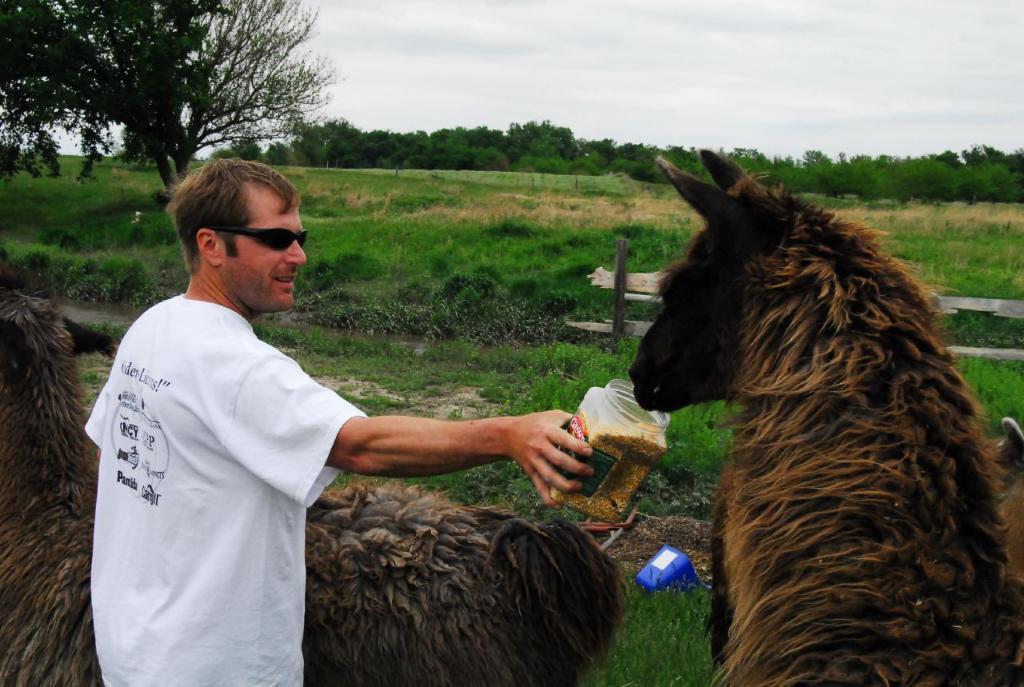Please provide a concise description of this image. In this picture we can see a man holding an object. On the left and right side of the man, there are animals. Behind the man, there are trees, fence and grass. At the top of the image, there is the cloudy sky. 